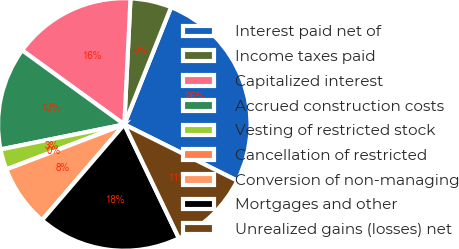Convert chart. <chart><loc_0><loc_0><loc_500><loc_500><pie_chart><fcel>Interest paid net of<fcel>Income taxes paid<fcel>Capitalized interest<fcel>Accrued construction costs<fcel>Vesting of restricted stock<fcel>Cancellation of restricted<fcel>Conversion of non-managing<fcel>Mortgages and other<fcel>Unrealized gains (losses) net<nl><fcel>26.31%<fcel>5.26%<fcel>15.79%<fcel>13.16%<fcel>2.63%<fcel>0.0%<fcel>7.9%<fcel>18.42%<fcel>10.53%<nl></chart> 